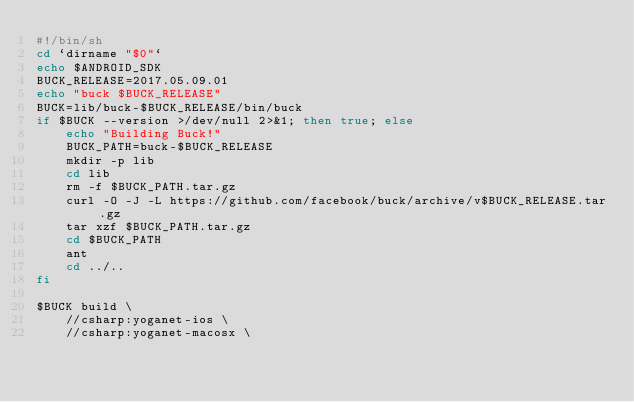Convert code to text. <code><loc_0><loc_0><loc_500><loc_500><_Bash_>#!/bin/sh
cd `dirname "$0"`
echo $ANDROID_SDK
BUCK_RELEASE=2017.05.09.01
echo "buck $BUCK_RELEASE"
BUCK=lib/buck-$BUCK_RELEASE/bin/buck
if $BUCK --version >/dev/null 2>&1; then true; else
    echo "Building Buck!"
    BUCK_PATH=buck-$BUCK_RELEASE
    mkdir -p lib
    cd lib
    rm -f $BUCK_PATH.tar.gz
    curl -O -J -L https://github.com/facebook/buck/archive/v$BUCK_RELEASE.tar.gz
    tar xzf $BUCK_PATH.tar.gz
    cd $BUCK_PATH
    ant
    cd ../..
fi

$BUCK build \
    //csharp:yoganet-ios \
    //csharp:yoganet-macosx \</code> 